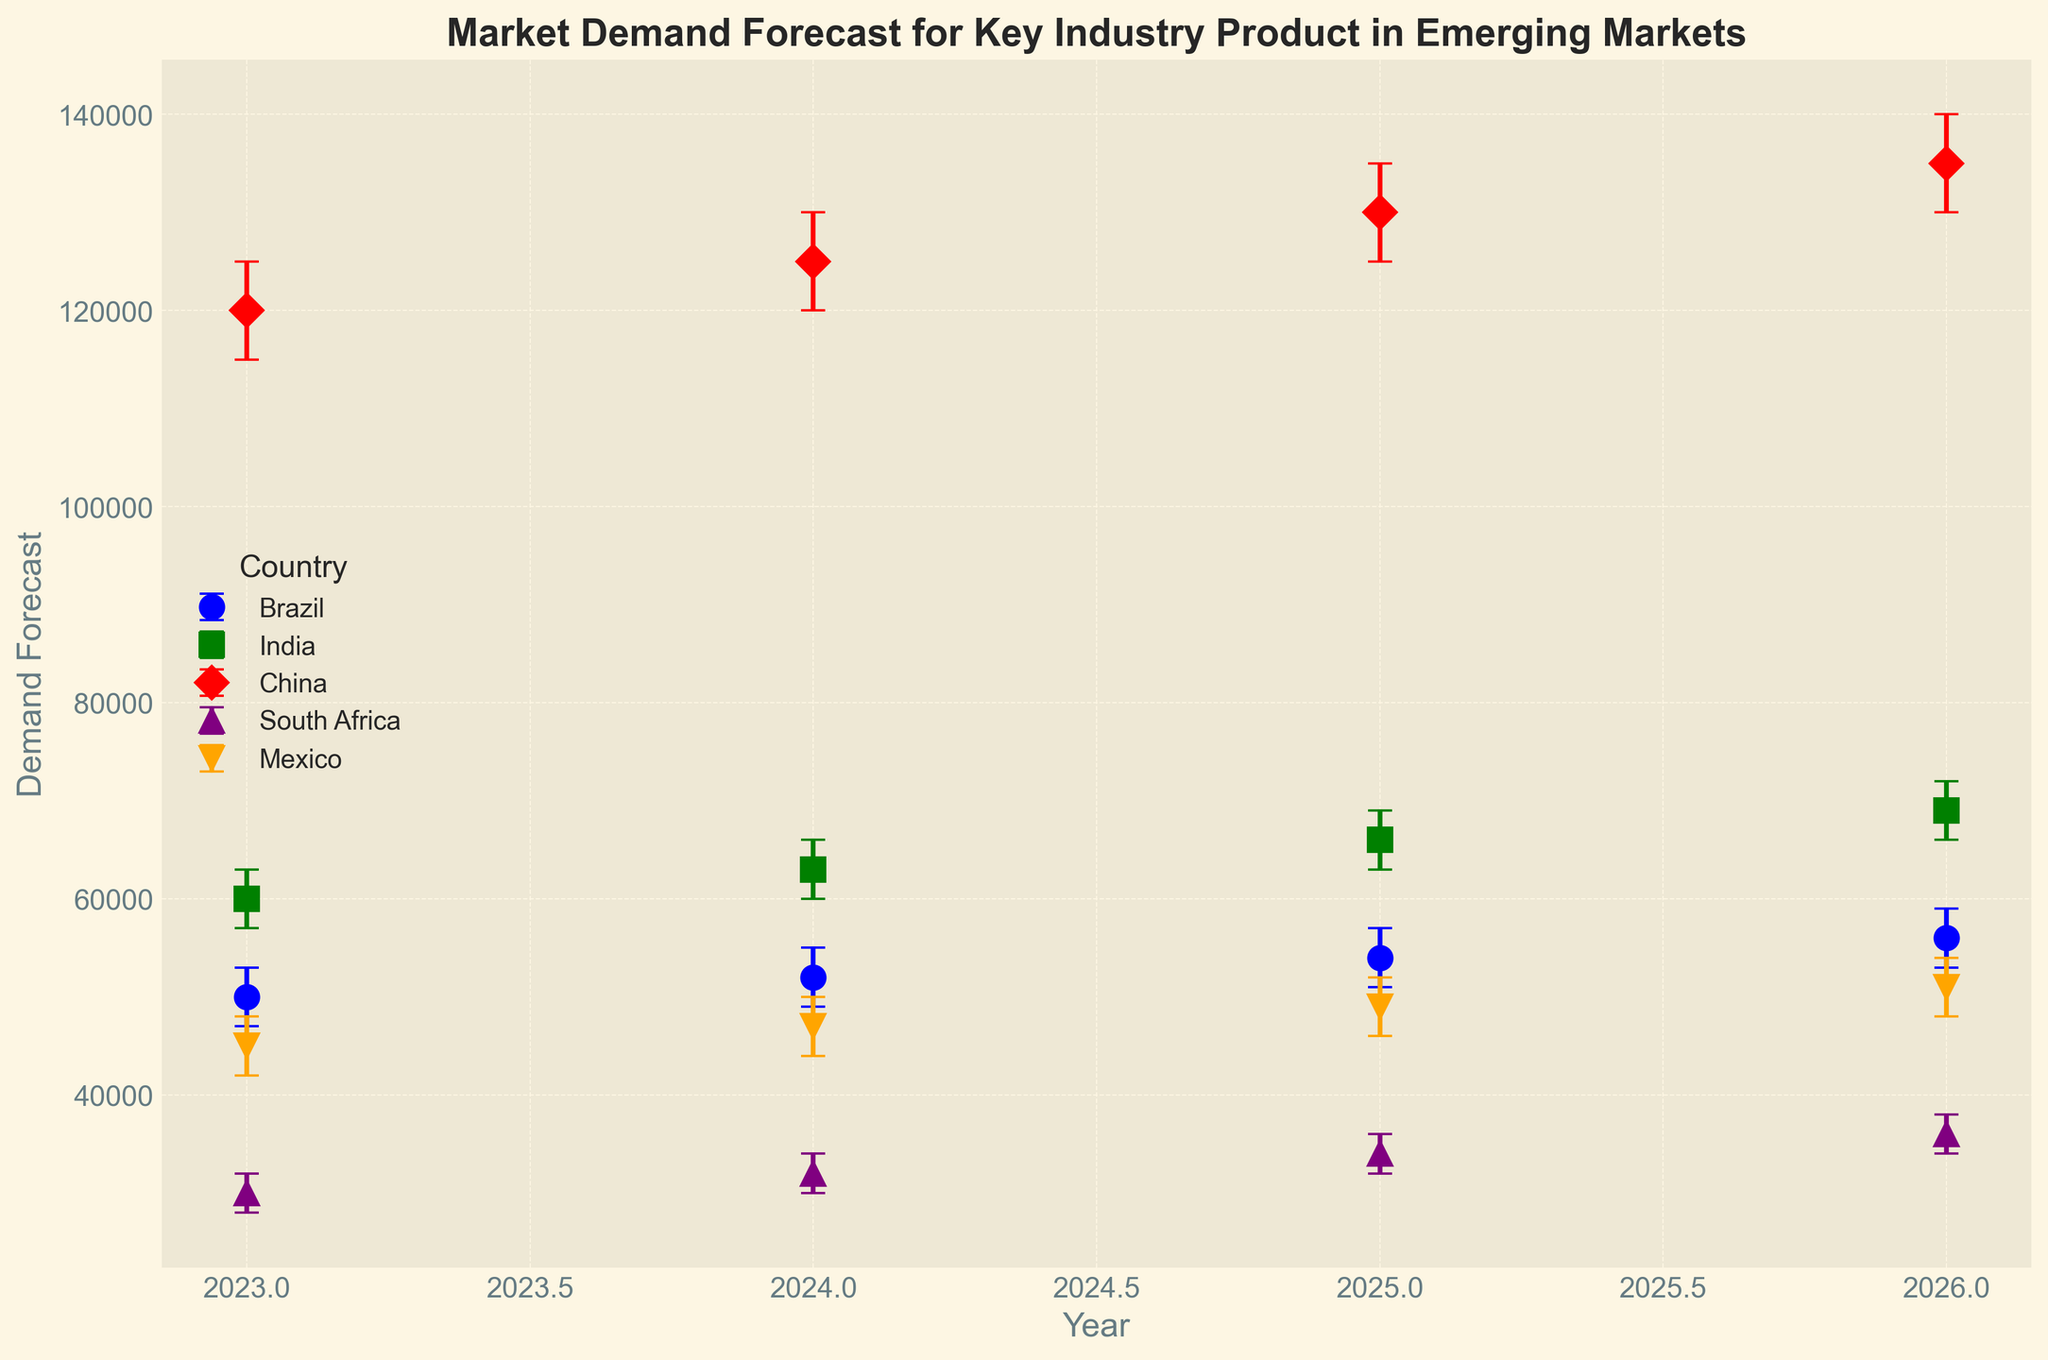What is the range of demand forecast for Brazil in 2025? The chart will show the demand forecast value with its prediction intervals for each year. To find the range, look at the upper and lower bounds for Brazil in 2025. The upper bound is 57,000 and the lower bound is 51,000. The range is the difference between these two values: 57,000 - 51,000.
Answer: 6,000 Which country has the highest demand forecast in 2026? To answer this, identify the highest demand forecast value shown on the chart for 2026 and determine which country it corresponds to. The highest forecast in 2026 is 135,000, which belongs to China.
Answer: China How does the forecasted demand for India in 2024 compare to that of Mexico in 2024? Look at the forecasted values for India and Mexico in 2024. The forecasted demand for India is 63,000, and for Mexico, it is 47,000. India’s forecast is higher than Mexico’s.
Answer: India's demand is higher Which country has the smallest prediction interval in 2025? Find the countries' demand forecasts along with their upper and lower bounds for 2025 and calculate the difference (the prediction interval) for each. The country with the smallest interval is the one with the smallest difference between the upper and lower bounds. South Africa's interval is 4,000 (36,000 - 32,000).
Answer: South Africa What is the average demand forecast across all countries in 2023? Add up the demand forecast values for all countries in 2023 and divide by the number of countries. The values are 50,000 (Brazil) + 60,000 (India) + 120,000 (China) + 30,000 (South Africa) + 45,000 (Mexico) = 305,000. The average is 305,000 / 5.
Answer: 61,000 What trend can be observed in the demand forecast for South Africa from 2023 to 2026? Look at the demand forecast values for South Africa from 2023 to 2026 on the chart. The values are 30,000 in 2023, 32,000 in 2024, 34,000 in 2025, and 36,000 in 2026. The trend shows a steady increase in demand forecast for South Africa over the years.
Answer: Steady increase For which year is the prediction interval widest for China? Check the prediction intervals for China from 2023 to 2026. Calculate the differences (prediction intervals) for each year: 2023 (10,000), 2024 (10,000), 2025 (10,000), 2026 (10,000). The intervals are all the same.
Answer: All years have the same interval By how much does Brazil's demand forecast increase from 2023 to 2026? Look at the demand forecast values for Brazil in 2023 and 2026. The values are 50,000 in 2023 and 56,000 in 2026. The increase is the difference: 56,000 - 50,000.
Answer: 6,000 Which country shows the most significant increase in demand forecast from 2023 to 2024? Compare the differences in demand forecast from 2023 to 2024 for each country. India: 63,000 - 60,000 = 3,000; Brazil: 52,000 - 50,000 = 2,000; China: 125,000 - 120,000 = 5,000; South Africa: 32,000 - 30,000 = 2,000; Mexico: 47,000 - 45,000 = 2,000. The most significant increase is for China.
Answer: China 